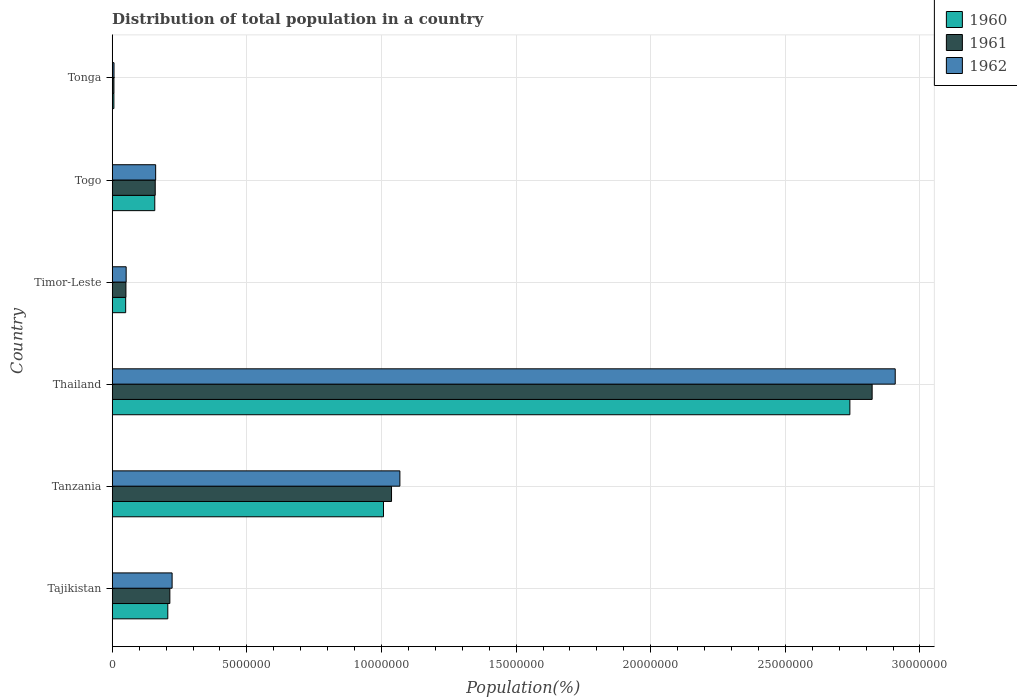How many groups of bars are there?
Give a very brief answer. 6. Are the number of bars on each tick of the Y-axis equal?
Your answer should be compact. Yes. What is the label of the 5th group of bars from the top?
Ensure brevity in your answer.  Tanzania. What is the population of in 1960 in Thailand?
Make the answer very short. 2.74e+07. Across all countries, what is the maximum population of in 1961?
Provide a short and direct response. 2.82e+07. Across all countries, what is the minimum population of in 1961?
Your answer should be compact. 6.37e+04. In which country was the population of in 1960 maximum?
Your answer should be very brief. Thailand. In which country was the population of in 1962 minimum?
Your answer should be compact. Tonga. What is the total population of in 1961 in the graph?
Give a very brief answer. 4.29e+07. What is the difference between the population of in 1960 in Tanzania and that in Thailand?
Offer a very short reply. -1.73e+07. What is the difference between the population of in 1960 in Tonga and the population of in 1962 in Timor-Leste?
Ensure brevity in your answer.  -4.56e+05. What is the average population of in 1961 per country?
Your answer should be very brief. 7.15e+06. What is the difference between the population of in 1961 and population of in 1962 in Tanzania?
Provide a succinct answer. -3.11e+05. In how many countries, is the population of in 1960 greater than 5000000 %?
Offer a terse response. 2. What is the ratio of the population of in 1962 in Tajikistan to that in Timor-Leste?
Your answer should be very brief. 4.3. What is the difference between the highest and the second highest population of in 1962?
Offer a terse response. 1.84e+07. What is the difference between the highest and the lowest population of in 1961?
Ensure brevity in your answer.  2.82e+07. In how many countries, is the population of in 1962 greater than the average population of in 1962 taken over all countries?
Your answer should be compact. 2. Is the sum of the population of in 1961 in Tajikistan and Timor-Leste greater than the maximum population of in 1962 across all countries?
Provide a short and direct response. No. What does the 3rd bar from the top in Thailand represents?
Offer a very short reply. 1960. Are all the bars in the graph horizontal?
Make the answer very short. Yes. How many countries are there in the graph?
Your answer should be very brief. 6. What is the difference between two consecutive major ticks on the X-axis?
Your answer should be compact. 5.00e+06. Are the values on the major ticks of X-axis written in scientific E-notation?
Offer a terse response. No. Does the graph contain any zero values?
Offer a terse response. No. Does the graph contain grids?
Offer a terse response. Yes. How many legend labels are there?
Your answer should be very brief. 3. What is the title of the graph?
Offer a very short reply. Distribution of total population in a country. Does "1990" appear as one of the legend labels in the graph?
Ensure brevity in your answer.  No. What is the label or title of the X-axis?
Offer a very short reply. Population(%). What is the Population(%) in 1960 in Tajikistan?
Your answer should be very brief. 2.06e+06. What is the Population(%) of 1961 in Tajikistan?
Provide a succinct answer. 2.14e+06. What is the Population(%) in 1962 in Tajikistan?
Your answer should be compact. 2.22e+06. What is the Population(%) in 1960 in Tanzania?
Make the answer very short. 1.01e+07. What is the Population(%) in 1961 in Tanzania?
Make the answer very short. 1.04e+07. What is the Population(%) in 1962 in Tanzania?
Offer a terse response. 1.07e+07. What is the Population(%) of 1960 in Thailand?
Provide a succinct answer. 2.74e+07. What is the Population(%) in 1961 in Thailand?
Your answer should be very brief. 2.82e+07. What is the Population(%) in 1962 in Thailand?
Keep it short and to the point. 2.91e+07. What is the Population(%) in 1960 in Timor-Leste?
Ensure brevity in your answer.  5.00e+05. What is the Population(%) in 1961 in Timor-Leste?
Make the answer very short. 5.08e+05. What is the Population(%) of 1962 in Timor-Leste?
Keep it short and to the point. 5.17e+05. What is the Population(%) of 1960 in Togo?
Your answer should be compact. 1.58e+06. What is the Population(%) in 1961 in Togo?
Your answer should be compact. 1.60e+06. What is the Population(%) in 1962 in Togo?
Your answer should be compact. 1.61e+06. What is the Population(%) in 1960 in Tonga?
Make the answer very short. 6.16e+04. What is the Population(%) in 1961 in Tonga?
Make the answer very short. 6.37e+04. What is the Population(%) of 1962 in Tonga?
Your answer should be compact. 6.63e+04. Across all countries, what is the maximum Population(%) of 1960?
Your response must be concise. 2.74e+07. Across all countries, what is the maximum Population(%) of 1961?
Provide a succinct answer. 2.82e+07. Across all countries, what is the maximum Population(%) in 1962?
Your response must be concise. 2.91e+07. Across all countries, what is the minimum Population(%) in 1960?
Ensure brevity in your answer.  6.16e+04. Across all countries, what is the minimum Population(%) in 1961?
Give a very brief answer. 6.37e+04. Across all countries, what is the minimum Population(%) of 1962?
Ensure brevity in your answer.  6.63e+04. What is the total Population(%) in 1960 in the graph?
Your answer should be compact. 4.17e+07. What is the total Population(%) of 1961 in the graph?
Give a very brief answer. 4.29e+07. What is the total Population(%) of 1962 in the graph?
Make the answer very short. 4.42e+07. What is the difference between the Population(%) of 1960 in Tajikistan and that in Tanzania?
Your answer should be compact. -8.01e+06. What is the difference between the Population(%) of 1961 in Tajikistan and that in Tanzania?
Keep it short and to the point. -8.23e+06. What is the difference between the Population(%) in 1962 in Tajikistan and that in Tanzania?
Your answer should be compact. -8.46e+06. What is the difference between the Population(%) in 1960 in Tajikistan and that in Thailand?
Your response must be concise. -2.53e+07. What is the difference between the Population(%) of 1961 in Tajikistan and that in Thailand?
Your answer should be compact. -2.61e+07. What is the difference between the Population(%) in 1962 in Tajikistan and that in Thailand?
Your response must be concise. -2.69e+07. What is the difference between the Population(%) in 1960 in Tajikistan and that in Timor-Leste?
Provide a succinct answer. 1.56e+06. What is the difference between the Population(%) in 1961 in Tajikistan and that in Timor-Leste?
Keep it short and to the point. 1.63e+06. What is the difference between the Population(%) of 1962 in Tajikistan and that in Timor-Leste?
Your response must be concise. 1.71e+06. What is the difference between the Population(%) of 1960 in Tajikistan and that in Togo?
Provide a succinct answer. 4.84e+05. What is the difference between the Population(%) in 1961 in Tajikistan and that in Togo?
Your response must be concise. 5.43e+05. What is the difference between the Population(%) of 1962 in Tajikistan and that in Togo?
Offer a very short reply. 6.11e+05. What is the difference between the Population(%) in 1960 in Tajikistan and that in Tonga?
Make the answer very short. 2.00e+06. What is the difference between the Population(%) of 1961 in Tajikistan and that in Tonga?
Keep it short and to the point. 2.08e+06. What is the difference between the Population(%) in 1962 in Tajikistan and that in Tonga?
Offer a terse response. 2.16e+06. What is the difference between the Population(%) of 1960 in Tanzania and that in Thailand?
Provide a succinct answer. -1.73e+07. What is the difference between the Population(%) of 1961 in Tanzania and that in Thailand?
Make the answer very short. -1.79e+07. What is the difference between the Population(%) of 1962 in Tanzania and that in Thailand?
Your response must be concise. -1.84e+07. What is the difference between the Population(%) in 1960 in Tanzania and that in Timor-Leste?
Keep it short and to the point. 9.57e+06. What is the difference between the Population(%) in 1961 in Tanzania and that in Timor-Leste?
Make the answer very short. 9.87e+06. What is the difference between the Population(%) in 1962 in Tanzania and that in Timor-Leste?
Keep it short and to the point. 1.02e+07. What is the difference between the Population(%) of 1960 in Tanzania and that in Togo?
Make the answer very short. 8.49e+06. What is the difference between the Population(%) of 1961 in Tanzania and that in Togo?
Ensure brevity in your answer.  8.78e+06. What is the difference between the Population(%) in 1962 in Tanzania and that in Togo?
Your response must be concise. 9.07e+06. What is the difference between the Population(%) in 1960 in Tanzania and that in Tonga?
Your answer should be very brief. 1.00e+07. What is the difference between the Population(%) in 1961 in Tanzania and that in Tonga?
Your response must be concise. 1.03e+07. What is the difference between the Population(%) of 1962 in Tanzania and that in Tonga?
Your answer should be compact. 1.06e+07. What is the difference between the Population(%) in 1960 in Thailand and that in Timor-Leste?
Ensure brevity in your answer.  2.69e+07. What is the difference between the Population(%) of 1961 in Thailand and that in Timor-Leste?
Offer a terse response. 2.77e+07. What is the difference between the Population(%) of 1962 in Thailand and that in Timor-Leste?
Provide a short and direct response. 2.86e+07. What is the difference between the Population(%) in 1960 in Thailand and that in Togo?
Ensure brevity in your answer.  2.58e+07. What is the difference between the Population(%) in 1961 in Thailand and that in Togo?
Keep it short and to the point. 2.66e+07. What is the difference between the Population(%) in 1962 in Thailand and that in Togo?
Your answer should be very brief. 2.75e+07. What is the difference between the Population(%) in 1960 in Thailand and that in Tonga?
Ensure brevity in your answer.  2.73e+07. What is the difference between the Population(%) in 1961 in Thailand and that in Tonga?
Keep it short and to the point. 2.82e+07. What is the difference between the Population(%) in 1962 in Thailand and that in Tonga?
Ensure brevity in your answer.  2.90e+07. What is the difference between the Population(%) in 1960 in Timor-Leste and that in Togo?
Your response must be concise. -1.08e+06. What is the difference between the Population(%) in 1961 in Timor-Leste and that in Togo?
Keep it short and to the point. -1.09e+06. What is the difference between the Population(%) of 1962 in Timor-Leste and that in Togo?
Offer a very short reply. -1.10e+06. What is the difference between the Population(%) in 1960 in Timor-Leste and that in Tonga?
Your answer should be compact. 4.38e+05. What is the difference between the Population(%) of 1961 in Timor-Leste and that in Tonga?
Give a very brief answer. 4.45e+05. What is the difference between the Population(%) of 1962 in Timor-Leste and that in Tonga?
Provide a succinct answer. 4.51e+05. What is the difference between the Population(%) in 1960 in Togo and that in Tonga?
Make the answer very short. 1.52e+06. What is the difference between the Population(%) in 1961 in Togo and that in Tonga?
Your answer should be very brief. 1.53e+06. What is the difference between the Population(%) of 1962 in Togo and that in Tonga?
Give a very brief answer. 1.55e+06. What is the difference between the Population(%) of 1960 in Tajikistan and the Population(%) of 1961 in Tanzania?
Your answer should be compact. -8.31e+06. What is the difference between the Population(%) of 1960 in Tajikistan and the Population(%) of 1962 in Tanzania?
Your response must be concise. -8.62e+06. What is the difference between the Population(%) of 1961 in Tajikistan and the Population(%) of 1962 in Tanzania?
Ensure brevity in your answer.  -8.54e+06. What is the difference between the Population(%) of 1960 in Tajikistan and the Population(%) of 1961 in Thailand?
Your response must be concise. -2.62e+07. What is the difference between the Population(%) of 1960 in Tajikistan and the Population(%) of 1962 in Thailand?
Ensure brevity in your answer.  -2.70e+07. What is the difference between the Population(%) in 1961 in Tajikistan and the Population(%) in 1962 in Thailand?
Keep it short and to the point. -2.69e+07. What is the difference between the Population(%) of 1960 in Tajikistan and the Population(%) of 1961 in Timor-Leste?
Provide a succinct answer. 1.56e+06. What is the difference between the Population(%) in 1960 in Tajikistan and the Population(%) in 1962 in Timor-Leste?
Your answer should be compact. 1.55e+06. What is the difference between the Population(%) of 1961 in Tajikistan and the Population(%) of 1962 in Timor-Leste?
Your answer should be compact. 1.62e+06. What is the difference between the Population(%) in 1960 in Tajikistan and the Population(%) in 1961 in Togo?
Offer a terse response. 4.67e+05. What is the difference between the Population(%) in 1960 in Tajikistan and the Population(%) in 1962 in Togo?
Make the answer very short. 4.51e+05. What is the difference between the Population(%) of 1961 in Tajikistan and the Population(%) of 1962 in Togo?
Your response must be concise. 5.28e+05. What is the difference between the Population(%) of 1960 in Tajikistan and the Population(%) of 1961 in Tonga?
Provide a short and direct response. 2.00e+06. What is the difference between the Population(%) in 1960 in Tajikistan and the Population(%) in 1962 in Tonga?
Your answer should be compact. 2.00e+06. What is the difference between the Population(%) of 1961 in Tajikistan and the Population(%) of 1962 in Tonga?
Provide a short and direct response. 2.07e+06. What is the difference between the Population(%) in 1960 in Tanzania and the Population(%) in 1961 in Thailand?
Offer a terse response. -1.81e+07. What is the difference between the Population(%) in 1960 in Tanzania and the Population(%) in 1962 in Thailand?
Provide a short and direct response. -1.90e+07. What is the difference between the Population(%) in 1961 in Tanzania and the Population(%) in 1962 in Thailand?
Your response must be concise. -1.87e+07. What is the difference between the Population(%) of 1960 in Tanzania and the Population(%) of 1961 in Timor-Leste?
Offer a terse response. 9.57e+06. What is the difference between the Population(%) in 1960 in Tanzania and the Population(%) in 1962 in Timor-Leste?
Your answer should be compact. 9.56e+06. What is the difference between the Population(%) of 1961 in Tanzania and the Population(%) of 1962 in Timor-Leste?
Make the answer very short. 9.86e+06. What is the difference between the Population(%) in 1960 in Tanzania and the Population(%) in 1961 in Togo?
Your answer should be very brief. 8.48e+06. What is the difference between the Population(%) of 1960 in Tanzania and the Population(%) of 1962 in Togo?
Provide a short and direct response. 8.46e+06. What is the difference between the Population(%) in 1961 in Tanzania and the Population(%) in 1962 in Togo?
Provide a succinct answer. 8.76e+06. What is the difference between the Population(%) of 1960 in Tanzania and the Population(%) of 1961 in Tonga?
Your response must be concise. 1.00e+07. What is the difference between the Population(%) of 1960 in Tanzania and the Population(%) of 1962 in Tonga?
Make the answer very short. 1.00e+07. What is the difference between the Population(%) in 1961 in Tanzania and the Population(%) in 1962 in Tonga?
Give a very brief answer. 1.03e+07. What is the difference between the Population(%) in 1960 in Thailand and the Population(%) in 1961 in Timor-Leste?
Keep it short and to the point. 2.69e+07. What is the difference between the Population(%) of 1960 in Thailand and the Population(%) of 1962 in Timor-Leste?
Your answer should be very brief. 2.69e+07. What is the difference between the Population(%) of 1961 in Thailand and the Population(%) of 1962 in Timor-Leste?
Make the answer very short. 2.77e+07. What is the difference between the Population(%) of 1960 in Thailand and the Population(%) of 1961 in Togo?
Your answer should be very brief. 2.58e+07. What is the difference between the Population(%) of 1960 in Thailand and the Population(%) of 1962 in Togo?
Provide a succinct answer. 2.58e+07. What is the difference between the Population(%) of 1961 in Thailand and the Population(%) of 1962 in Togo?
Give a very brief answer. 2.66e+07. What is the difference between the Population(%) of 1960 in Thailand and the Population(%) of 1961 in Tonga?
Your response must be concise. 2.73e+07. What is the difference between the Population(%) in 1960 in Thailand and the Population(%) in 1962 in Tonga?
Your answer should be very brief. 2.73e+07. What is the difference between the Population(%) of 1961 in Thailand and the Population(%) of 1962 in Tonga?
Offer a very short reply. 2.82e+07. What is the difference between the Population(%) of 1960 in Timor-Leste and the Population(%) of 1961 in Togo?
Offer a terse response. -1.10e+06. What is the difference between the Population(%) in 1960 in Timor-Leste and the Population(%) in 1962 in Togo?
Give a very brief answer. -1.11e+06. What is the difference between the Population(%) of 1961 in Timor-Leste and the Population(%) of 1962 in Togo?
Keep it short and to the point. -1.10e+06. What is the difference between the Population(%) of 1960 in Timor-Leste and the Population(%) of 1961 in Tonga?
Ensure brevity in your answer.  4.36e+05. What is the difference between the Population(%) of 1960 in Timor-Leste and the Population(%) of 1962 in Tonga?
Provide a succinct answer. 4.33e+05. What is the difference between the Population(%) in 1961 in Timor-Leste and the Population(%) in 1962 in Tonga?
Provide a succinct answer. 4.42e+05. What is the difference between the Population(%) of 1960 in Togo and the Population(%) of 1961 in Tonga?
Provide a succinct answer. 1.52e+06. What is the difference between the Population(%) in 1960 in Togo and the Population(%) in 1962 in Tonga?
Provide a short and direct response. 1.51e+06. What is the difference between the Population(%) of 1961 in Togo and the Population(%) of 1962 in Tonga?
Keep it short and to the point. 1.53e+06. What is the average Population(%) of 1960 per country?
Offer a very short reply. 6.95e+06. What is the average Population(%) of 1961 per country?
Your answer should be compact. 7.15e+06. What is the average Population(%) of 1962 per country?
Provide a short and direct response. 7.36e+06. What is the difference between the Population(%) in 1960 and Population(%) in 1961 in Tajikistan?
Ensure brevity in your answer.  -7.64e+04. What is the difference between the Population(%) in 1960 and Population(%) in 1962 in Tajikistan?
Offer a terse response. -1.60e+05. What is the difference between the Population(%) in 1961 and Population(%) in 1962 in Tajikistan?
Ensure brevity in your answer.  -8.35e+04. What is the difference between the Population(%) of 1960 and Population(%) of 1961 in Tanzania?
Ensure brevity in your answer.  -2.99e+05. What is the difference between the Population(%) of 1960 and Population(%) of 1962 in Tanzania?
Offer a very short reply. -6.09e+05. What is the difference between the Population(%) of 1961 and Population(%) of 1962 in Tanzania?
Give a very brief answer. -3.11e+05. What is the difference between the Population(%) of 1960 and Population(%) of 1961 in Thailand?
Give a very brief answer. -8.27e+05. What is the difference between the Population(%) in 1960 and Population(%) in 1962 in Thailand?
Offer a very short reply. -1.68e+06. What is the difference between the Population(%) of 1961 and Population(%) of 1962 in Thailand?
Your answer should be compact. -8.57e+05. What is the difference between the Population(%) of 1960 and Population(%) of 1961 in Timor-Leste?
Your response must be concise. -8786. What is the difference between the Population(%) of 1960 and Population(%) of 1962 in Timor-Leste?
Offer a very short reply. -1.79e+04. What is the difference between the Population(%) of 1961 and Population(%) of 1962 in Timor-Leste?
Your answer should be compact. -9135. What is the difference between the Population(%) in 1960 and Population(%) in 1961 in Togo?
Offer a very short reply. -1.70e+04. What is the difference between the Population(%) in 1960 and Population(%) in 1962 in Togo?
Your answer should be very brief. -3.22e+04. What is the difference between the Population(%) of 1961 and Population(%) of 1962 in Togo?
Keep it short and to the point. -1.52e+04. What is the difference between the Population(%) in 1960 and Population(%) in 1961 in Tonga?
Offer a terse response. -2140. What is the difference between the Population(%) in 1960 and Population(%) in 1962 in Tonga?
Keep it short and to the point. -4655. What is the difference between the Population(%) in 1961 and Population(%) in 1962 in Tonga?
Make the answer very short. -2515. What is the ratio of the Population(%) in 1960 in Tajikistan to that in Tanzania?
Ensure brevity in your answer.  0.2. What is the ratio of the Population(%) in 1961 in Tajikistan to that in Tanzania?
Provide a short and direct response. 0.21. What is the ratio of the Population(%) of 1962 in Tajikistan to that in Tanzania?
Your answer should be very brief. 0.21. What is the ratio of the Population(%) of 1960 in Tajikistan to that in Thailand?
Offer a terse response. 0.08. What is the ratio of the Population(%) of 1961 in Tajikistan to that in Thailand?
Provide a succinct answer. 0.08. What is the ratio of the Population(%) in 1962 in Tajikistan to that in Thailand?
Your response must be concise. 0.08. What is the ratio of the Population(%) of 1960 in Tajikistan to that in Timor-Leste?
Provide a short and direct response. 4.13. What is the ratio of the Population(%) of 1961 in Tajikistan to that in Timor-Leste?
Offer a terse response. 4.21. What is the ratio of the Population(%) of 1962 in Tajikistan to that in Timor-Leste?
Offer a terse response. 4.3. What is the ratio of the Population(%) in 1960 in Tajikistan to that in Togo?
Ensure brevity in your answer.  1.31. What is the ratio of the Population(%) in 1961 in Tajikistan to that in Togo?
Provide a succinct answer. 1.34. What is the ratio of the Population(%) in 1962 in Tajikistan to that in Togo?
Your answer should be very brief. 1.38. What is the ratio of the Population(%) of 1960 in Tajikistan to that in Tonga?
Keep it short and to the point. 33.51. What is the ratio of the Population(%) in 1961 in Tajikistan to that in Tonga?
Offer a very short reply. 33.58. What is the ratio of the Population(%) in 1962 in Tajikistan to that in Tonga?
Your response must be concise. 33.57. What is the ratio of the Population(%) in 1960 in Tanzania to that in Thailand?
Your answer should be compact. 0.37. What is the ratio of the Population(%) in 1961 in Tanzania to that in Thailand?
Make the answer very short. 0.37. What is the ratio of the Population(%) in 1962 in Tanzania to that in Thailand?
Keep it short and to the point. 0.37. What is the ratio of the Population(%) in 1960 in Tanzania to that in Timor-Leste?
Your response must be concise. 20.17. What is the ratio of the Population(%) in 1961 in Tanzania to that in Timor-Leste?
Give a very brief answer. 20.41. What is the ratio of the Population(%) in 1962 in Tanzania to that in Timor-Leste?
Your answer should be compact. 20.65. What is the ratio of the Population(%) in 1960 in Tanzania to that in Togo?
Keep it short and to the point. 6.37. What is the ratio of the Population(%) in 1961 in Tanzania to that in Togo?
Provide a short and direct response. 6.49. What is the ratio of the Population(%) of 1962 in Tanzania to that in Togo?
Offer a very short reply. 6.62. What is the ratio of the Population(%) of 1960 in Tanzania to that in Tonga?
Your answer should be very brief. 163.55. What is the ratio of the Population(%) of 1961 in Tanzania to that in Tonga?
Make the answer very short. 162.75. What is the ratio of the Population(%) in 1962 in Tanzania to that in Tonga?
Provide a succinct answer. 161.25. What is the ratio of the Population(%) in 1960 in Thailand to that in Timor-Leste?
Ensure brevity in your answer.  54.85. What is the ratio of the Population(%) of 1961 in Thailand to that in Timor-Leste?
Keep it short and to the point. 55.53. What is the ratio of the Population(%) of 1962 in Thailand to that in Timor-Leste?
Your answer should be very brief. 56.2. What is the ratio of the Population(%) in 1960 in Thailand to that in Togo?
Keep it short and to the point. 17.33. What is the ratio of the Population(%) in 1961 in Thailand to that in Togo?
Offer a terse response. 17.67. What is the ratio of the Population(%) of 1962 in Thailand to that in Togo?
Provide a short and direct response. 18.03. What is the ratio of the Population(%) of 1960 in Thailand to that in Tonga?
Give a very brief answer. 444.76. What is the ratio of the Population(%) in 1961 in Thailand to that in Tonga?
Your response must be concise. 442.8. What is the ratio of the Population(%) in 1962 in Thailand to that in Tonga?
Offer a terse response. 438.93. What is the ratio of the Population(%) of 1960 in Timor-Leste to that in Togo?
Offer a terse response. 0.32. What is the ratio of the Population(%) of 1961 in Timor-Leste to that in Togo?
Keep it short and to the point. 0.32. What is the ratio of the Population(%) in 1962 in Timor-Leste to that in Togo?
Offer a very short reply. 0.32. What is the ratio of the Population(%) in 1960 in Timor-Leste to that in Tonga?
Offer a very short reply. 8.11. What is the ratio of the Population(%) in 1961 in Timor-Leste to that in Tonga?
Make the answer very short. 7.97. What is the ratio of the Population(%) in 1962 in Timor-Leste to that in Tonga?
Make the answer very short. 7.81. What is the ratio of the Population(%) in 1960 in Togo to that in Tonga?
Ensure brevity in your answer.  25.66. What is the ratio of the Population(%) in 1961 in Togo to that in Tonga?
Your answer should be compact. 25.06. What is the ratio of the Population(%) in 1962 in Togo to that in Tonga?
Provide a succinct answer. 24.34. What is the difference between the highest and the second highest Population(%) of 1960?
Ensure brevity in your answer.  1.73e+07. What is the difference between the highest and the second highest Population(%) in 1961?
Your answer should be very brief. 1.79e+07. What is the difference between the highest and the second highest Population(%) in 1962?
Your response must be concise. 1.84e+07. What is the difference between the highest and the lowest Population(%) in 1960?
Your answer should be very brief. 2.73e+07. What is the difference between the highest and the lowest Population(%) in 1961?
Keep it short and to the point. 2.82e+07. What is the difference between the highest and the lowest Population(%) of 1962?
Your answer should be very brief. 2.90e+07. 